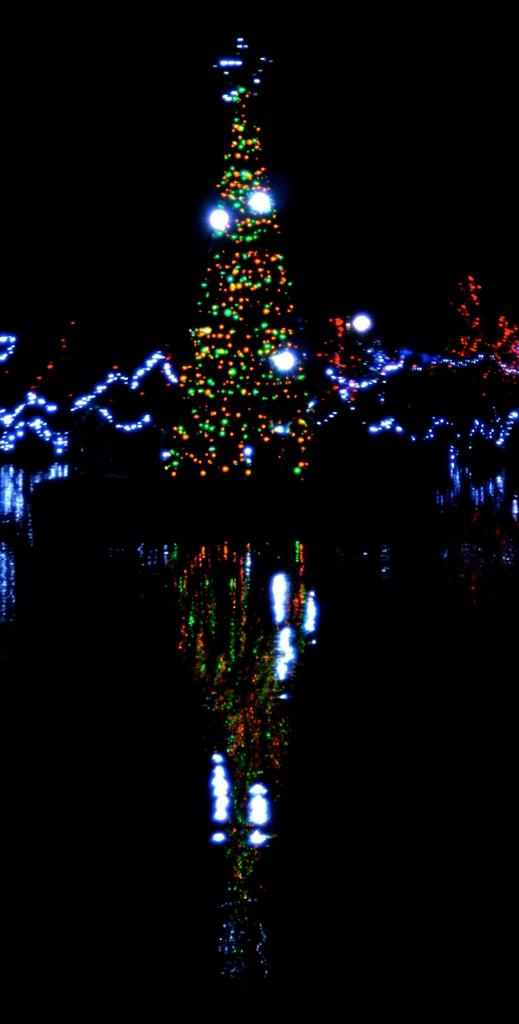What is the main subject of the image? The main subject of the image is a tree with lights. What can be observed about the tree's surroundings? The tree has a reflection in the water. What is the color of the background in the image? The background of the image is black. How many mice can be seen climbing the tree in the image? There are no mice present in the image; it features a tree with lights and a reflection in the water. What type of can is visible on the tree in the image? There is no can present in the image; it features a tree with lights and a reflection in the water. 